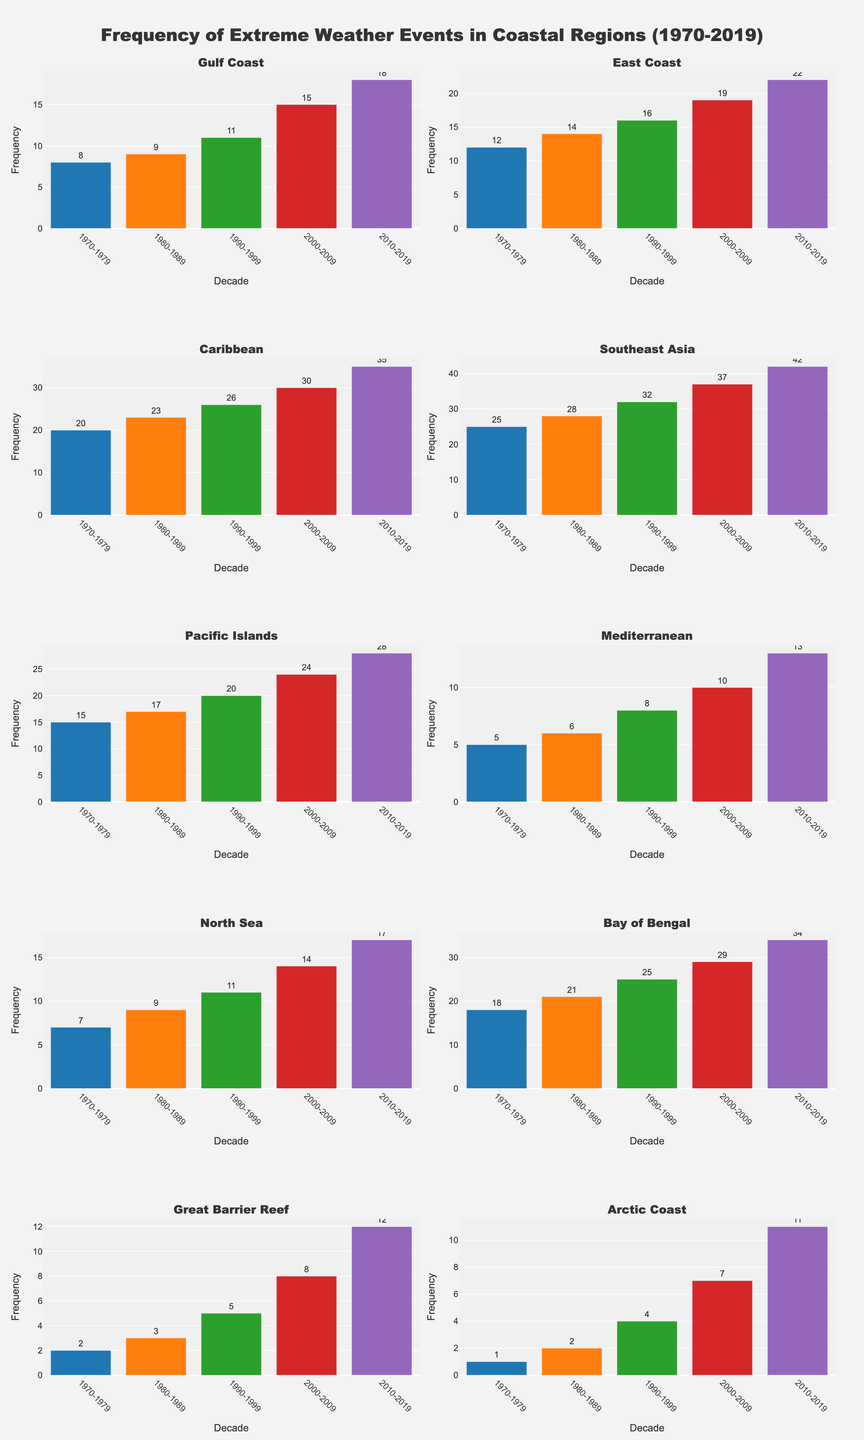Which region experienced the highest increase in the frequency of extreme weather events from 1970 to 2019? The region with the highest increase can be identified by comparing the frequencies in the first decade (1970-1979) and the last decade (2010-2019) for each region. The Caribbean had 20 events in 1970-1979 and 35 events in 2010-2019, resulting in an increase of 15 events.
Answer: Caribbean Which region had the lowest number of extreme weather events in the 1970-1979 decade? By looking at the frequency values for each region in the 1970-1979 decade, the Arctic Coast had the lowest number with only 1 event.
Answer: Arctic Coast How many more events did the Gulf Coast experience in the 2010-2019 decade compared to the 1970-1979 decade? In 1970-1979, the Gulf Coast experienced 8 events. In 2010-2019, it experienced 18 events. The difference is 18 - 8, which equals 10.
Answer: 10 Which region saw a more significant increase in events between 2000-2009 and 2010-2019: the East Coast or the Pacific Islands? The East Coast had 19 events in 2000-2009 and 22 events in 2010-2019, which is an increase of 3. The Pacific Islands had 24 events in 2000-2009 and 28 events in 2010-2019, which is an increase of 4. The Pacific Islands saw a more significant increase.
Answer: Pacific Islands What is the average frequency of Coral Bleaching Events in the Great Barrier Reef across all decades? The frequencies for the Great Barrier Reef are 2, 3, 5, 8, and 12. The sum is 2 + 3 + 5 + 8 + 12 = 30. The average is 30 / 5 = 6.
Answer: 6 Which region had the most frequent extreme weather events in the 1990-1999 decade? In the 1990-1999 decade, Southeast Asia had 32 events, which is the highest among all regions.
Answer: Southeast Asia What is the median frequency of Typhoons in Southeast Asia across all decades? The frequencies for Southeast Asia are 25, 28, 32, 37, and 42. Arranging these in order, the median is the middle value, which is 32.
Answer: 32 Between 1980-1989 and 1990-1999, did the frequency of Coastal Floods in the North Sea increase or decrease, and by how much? The North Sea had 9 Coastal Floods in 1980-1989 and 11 in 1990-1999. The frequency increased by 11 - 9 = 2 events.
Answer: Increased by 2 In which decade did the Mediterranean experience double the number of Storm Surges compared to the previous decade? Comparing each decade to the previous one, the Mediterranean experienced 5 Storm Surges in 1970-1979 and 10 in 2000-2009, which is exactly double.
Answer: 2000-2009 What is the total number of extreme weather events combined for all regions in the 2010-2019 decade? Summing up the frequencies for all regions in 2010-2019: 18 (Gulf Coast) + 22 (East Coast) + 35 (Caribbean) + 42 (Southeast Asia) + 28 (Pacific Islands) + 13 (Mediterranean) + 17 (North Sea) + 34 (Bay of Bengal) + 12 (Great Barrier Reef) + 11 (Arctic Coast) = 232.
Answer: 232 